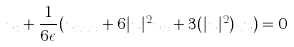Convert formula to latex. <formula><loc_0><loc_0><loc_500><loc_500>u _ { t } + \frac { 1 } { 6 \epsilon } ( u _ { x x x } + 6 | u | ^ { 2 } u _ { x } + 3 ( | u | ^ { 2 } ) _ { x } u ) = 0</formula> 